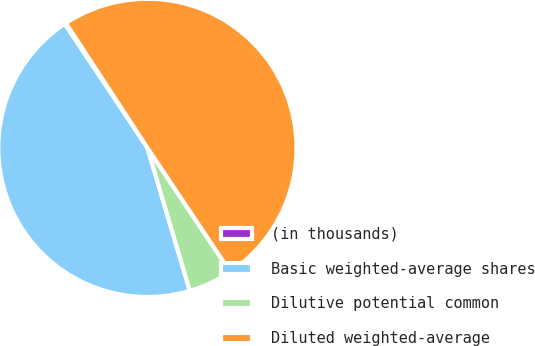<chart> <loc_0><loc_0><loc_500><loc_500><pie_chart><fcel>(in thousands)<fcel>Basic weighted-average shares<fcel>Dilutive potential common<fcel>Diluted weighted-average<nl><fcel>0.17%<fcel>45.21%<fcel>4.79%<fcel>49.83%<nl></chart> 